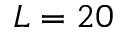<formula> <loc_0><loc_0><loc_500><loc_500>L = 2 0</formula> 